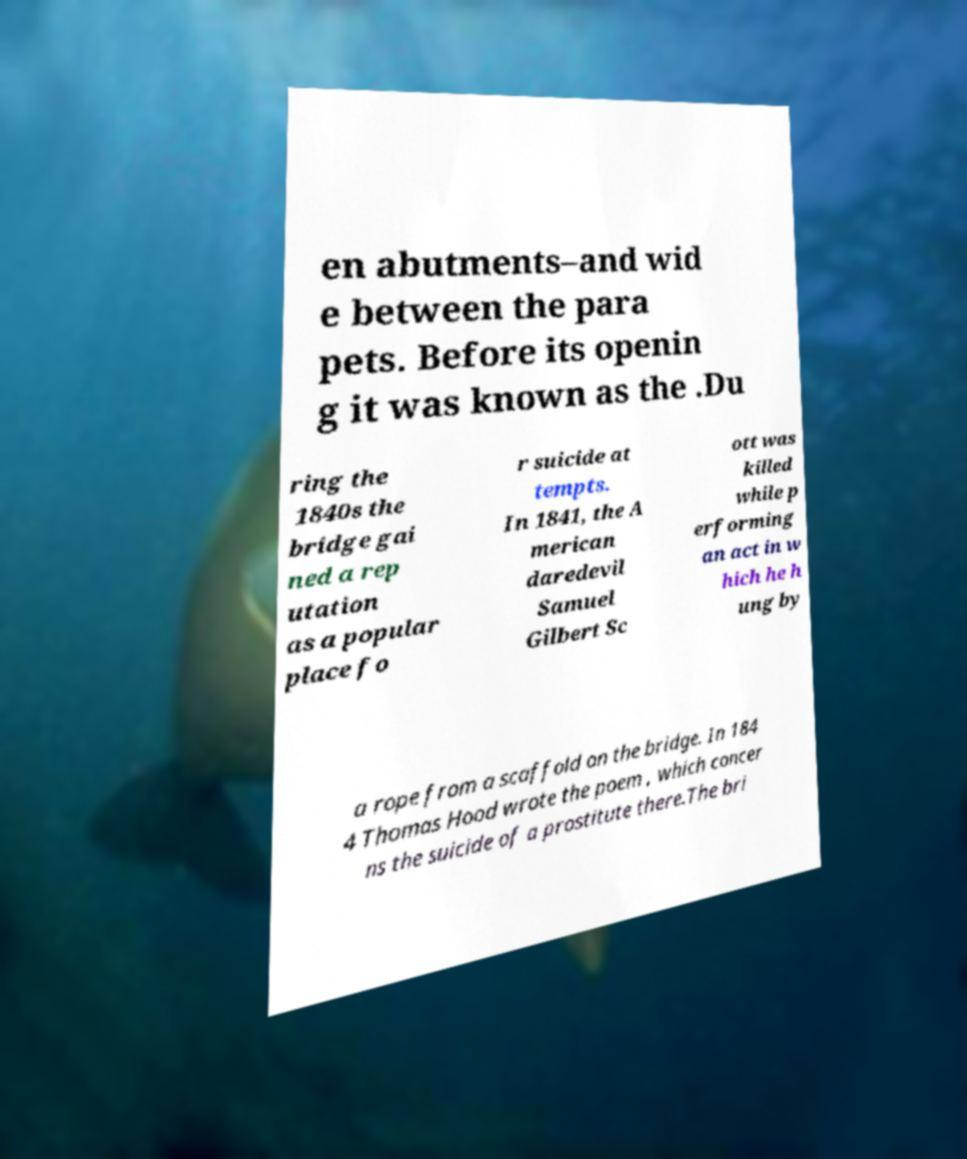Could you extract and type out the text from this image? en abutments–and wid e between the para pets. Before its openin g it was known as the .Du ring the 1840s the bridge gai ned a rep utation as a popular place fo r suicide at tempts. In 1841, the A merican daredevil Samuel Gilbert Sc ott was killed while p erforming an act in w hich he h ung by a rope from a scaffold on the bridge. In 184 4 Thomas Hood wrote the poem , which concer ns the suicide of a prostitute there.The bri 